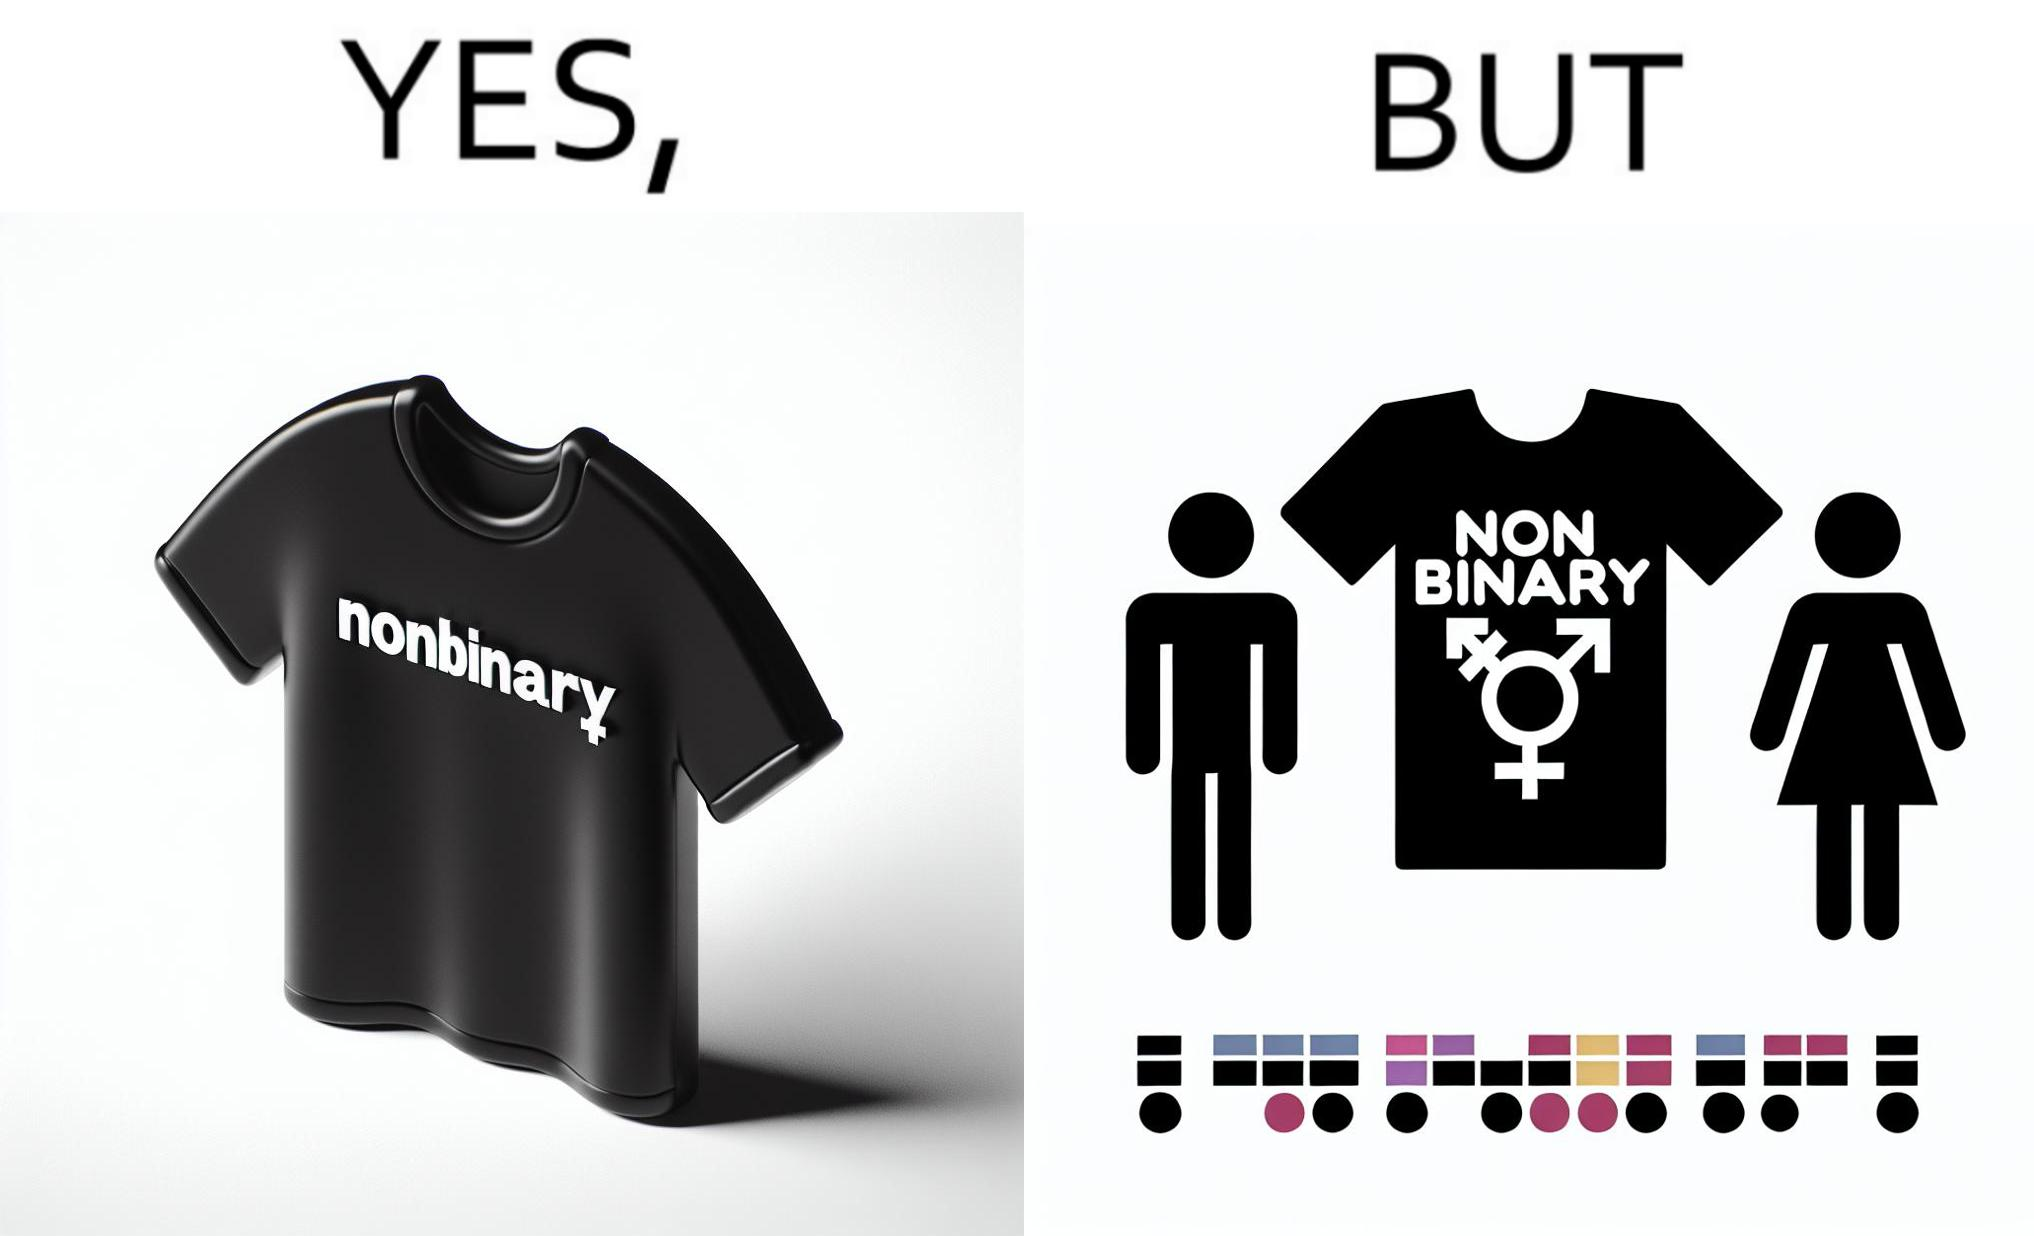Describe what you see in the left and right parts of this image. In the left part of the image: t-shirt with "NONBINARY" written on it. In the right part of the image: t-shirt with "NONBINARY" written on it, with several customizable options for color and 2 gender options on the right 